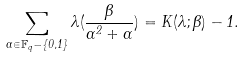Convert formula to latex. <formula><loc_0><loc_0><loc_500><loc_500>\sum _ { \alpha \in \mathbb { F } _ { q } - \{ 0 , 1 \} } \lambda ( \frac { \beta } { \alpha ^ { 2 } + \alpha } ) = K ( \lambda ; \beta ) - 1 .</formula> 